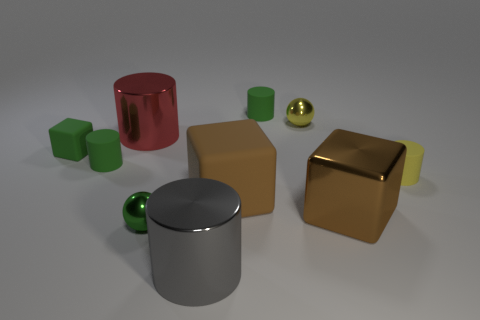Subtract all small cubes. How many cubes are left? 2 Subtract all red balls. How many green cylinders are left? 2 Subtract 1 blocks. How many blocks are left? 2 Subtract all red cylinders. How many cylinders are left? 4 Subtract all purple blocks. Subtract all gray cylinders. How many blocks are left? 3 Subtract all blocks. How many objects are left? 7 Subtract 0 gray balls. How many objects are left? 10 Subtract all metallic blocks. Subtract all big things. How many objects are left? 5 Add 8 brown metal things. How many brown metal things are left? 9 Add 2 big blocks. How many big blocks exist? 4 